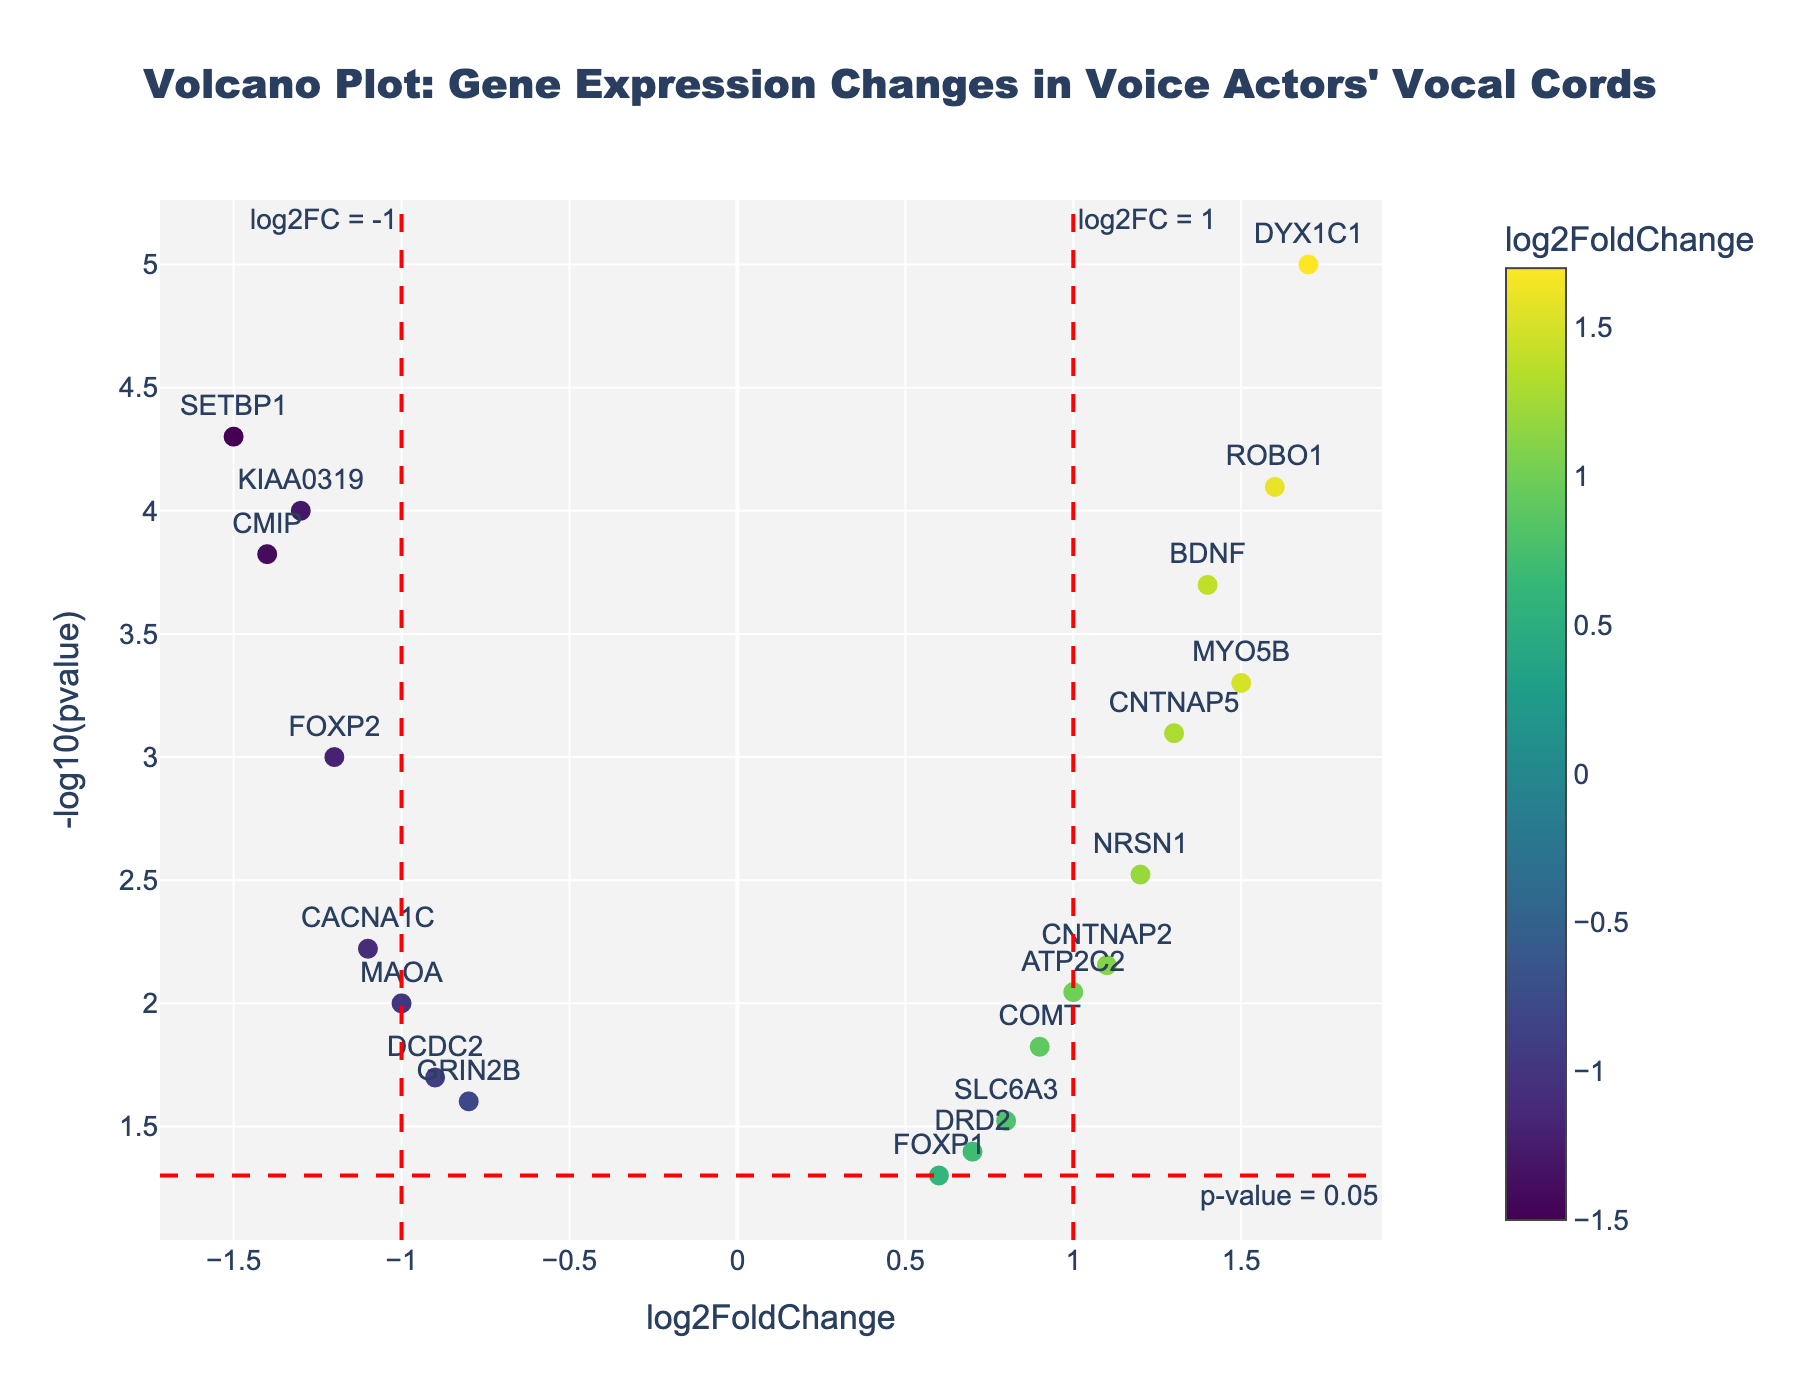what is the title of the figure? The title is typically displayed at the top of the figure, and in this case, it's centered with specific formatting.
Answer: Volcano Plot: Gene Expression Changes in Voice Actors' Vocal Cords How many data points have a p-value less than 0.05? A p-value less than 0.05 is indicated by points above the horizontal red dashed line (approximately 1.3 on the -log10(pvalue) scale). Count the points above this line.
Answer: 17 Which gene has the highest log2FoldChange and what is its value? The highest log2FoldChange is found by looking for the rightmost point on the x-axis. The gene label next to that point provides the answer.
Answer: DYX1C1 with log2FoldChange of 1.7 What is the range of log2FoldChange values displayed on the plot? To find the range, identify the minimum and maximum values on the x-axis where data points are present.
Answer: -1.5 to 1.7 Name the genes that have both a log2FoldChange less than -1 and a p-value less than 0.001? Look for points to the left of the x=-1 red vertical line and above the y=1.3 horizontal red line. Identify the gene labels for these points.
Answer: KIAA0319, SETBP1, CMIP How many genes have increased expression (positive log2FoldChange) and significant p-values (p<0.05)? Increased expression corresponds to points with log2FoldChange > 0, and p<0.05 is indicated by points above the horizontal red line. Count these points.
Answer: 8 Which gene has the lowest p-value and what is its -log10(pvalue)? The lowest p-value corresponds to the highest point on the y-axis. Identify the gene label next to this point and its y-value.
Answer: DYX1C1 with -log10(pvalue) of 5 Compare the expression levels between the genes FOXP2 and BDNF. Which one is more downregulated? Downregulation is indicated by negative log2FoldChange. Check the log2FoldChange values for both genes and compare them.
Answer: FOXP2 is more downregulated with log2FoldChange of -1.2 compared to BDNF's log2FoldChange of 1.4 Calculate the average log2FoldChange for genes with p-values less than 0.01. Identify genes with p-values less than 0.01 (above the horizontal line at y=2). Sum their log2FoldChange values and divide by the count of those genes.
Answer: (Sum of log2FoldChange values for qualifying genes) / Number of qualifying genes = 0.075 Which gene is closer to the threshold of log2FoldChange = 1 on the positive side? Identify the gene closest to x=1 on the positive side of the x-axis.
Answer: ATP2C2 